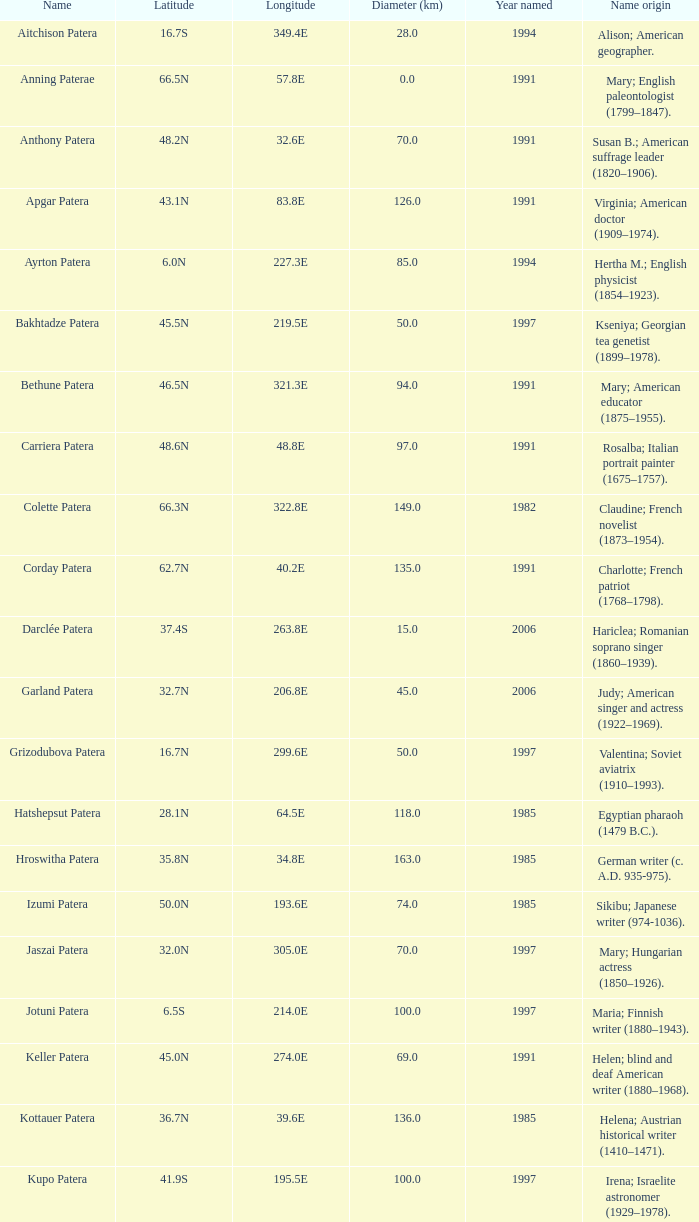2e? 135.0. Write the full table. {'header': ['Name', 'Latitude', 'Longitude', 'Diameter (km)', 'Year named', 'Name origin'], 'rows': [['Aitchison Patera', '16.7S', '349.4E', '28.0', '1994', 'Alison; American geographer.'], ['Anning Paterae', '66.5N', '57.8E', '0.0', '1991', 'Mary; English paleontologist (1799–1847).'], ['Anthony Patera', '48.2N', '32.6E', '70.0', '1991', 'Susan B.; American suffrage leader (1820–1906).'], ['Apgar Patera', '43.1N', '83.8E', '126.0', '1991', 'Virginia; American doctor (1909–1974).'], ['Ayrton Patera', '6.0N', '227.3E', '85.0', '1994', 'Hertha M.; English physicist (1854–1923).'], ['Bakhtadze Patera', '45.5N', '219.5E', '50.0', '1997', 'Kseniya; Georgian tea genetist (1899–1978).'], ['Bethune Patera', '46.5N', '321.3E', '94.0', '1991', 'Mary; American educator (1875–1955).'], ['Carriera Patera', '48.6N', '48.8E', '97.0', '1991', 'Rosalba; Italian portrait painter (1675–1757).'], ['Colette Patera', '66.3N', '322.8E', '149.0', '1982', 'Claudine; French novelist (1873–1954).'], ['Corday Patera', '62.7N', '40.2E', '135.0', '1991', 'Charlotte; French patriot (1768–1798).'], ['Darclée Patera', '37.4S', '263.8E', '15.0', '2006', 'Hariclea; Romanian soprano singer (1860–1939).'], ['Garland Patera', '32.7N', '206.8E', '45.0', '2006', 'Judy; American singer and actress (1922–1969).'], ['Grizodubova Patera', '16.7N', '299.6E', '50.0', '1997', 'Valentina; Soviet aviatrix (1910–1993).'], ['Hatshepsut Patera', '28.1N', '64.5E', '118.0', '1985', 'Egyptian pharaoh (1479 B.C.).'], ['Hroswitha Patera', '35.8N', '34.8E', '163.0', '1985', 'German writer (c. A.D. 935-975).'], ['Izumi Patera', '50.0N', '193.6E', '74.0', '1985', 'Sikibu; Japanese writer (974-1036).'], ['Jaszai Patera', '32.0N', '305.0E', '70.0', '1997', 'Mary; Hungarian actress (1850–1926).'], ['Jotuni Patera', '6.5S', '214.0E', '100.0', '1997', 'Maria; Finnish writer (1880–1943).'], ['Keller Patera', '45.0N', '274.0E', '69.0', '1991', 'Helen; blind and deaf American writer (1880–1968).'], ['Kottauer Patera', '36.7N', '39.6E', '136.0', '1985', 'Helena; Austrian historical writer (1410–1471).'], ['Kupo Patera', '41.9S', '195.5E', '100.0', '1997', 'Irena; Israelite astronomer (1929–1978).'], ['Ledoux Patera', '9.2S', '224.8E', '75.0', '1994', 'Jeanne; French artist (1767–1840).'], ['Lindgren Patera', '28.1N', '241.4E', '110.0', '2006', 'Astrid; Swedish author (1907–2002).'], ['Mehseti Patera', '16.0N', '311.0E', '60.0', '1997', 'Ganjevi; Azeri/Persian poet (c. 1050-c. 1100).'], ['Mezrina Patera', '33.3S', '68.8E', '60.0', '2000', 'Anna; Russian clay toy sculptor (1853–1938).'], ['Nordenflycht Patera', '35.0S', '266.0E', '140.0', '1997', 'Hedwig; Swedish poet (1718–1763).'], ['Panina Patera', '13.0S', '309.8E', '50.0', '1997', 'Varya; Gypsy/Russian singer (1872–1911).'], ['Payne-Gaposchkin Patera', '25.5S', '196.0E', '100.0', '1997', 'Cecilia Helena; American astronomer (1900–1979).'], ['Pocahontas Patera', '64.9N', '49.4E', '78.0', '1991', 'Powhatan Indian peacemaker (1595–1617).'], ['Raskova Paterae', '51.0S', '222.8E', '80.0', '1994', 'Marina M.; Russian aviator (1912–1943).'], ['Razia Patera', '46.2N', '197.8E', '157.0', '1985', 'Queen of Delhi Sultanate (India) (1236–1240).'], ['Shulzhenko Patera', '6.5N', '264.5E', '60.0', '1997', 'Klavdiya; Soviet singer (1906–1984).'], ['Siddons Patera', '61.6N', '340.6E', '47.0', '1997', 'Sarah; English actress (1755–1831).'], ['Stopes Patera', '42.6N', '46.5E', '169.0', '1991', 'Marie; English paleontologist (1880–1959).'], ['Tarbell Patera', '58.2S', '351.5E', '80.0', '1994', 'Ida; American author, editor (1857–1944).'], ['Teasdale Patera', '67.6S', '189.1E', '75.0', '1994', 'Sara; American poet (1884–1933).'], ['Tey Patera', '17.8S', '349.1E', '20.0', '1994', 'Josephine; Scottish author (1897–1952).'], ['Tipporah Patera', '38.9N', '43.0E', '99.0', '1985', 'Hebrew medical scholar (1500 B.C.).'], ['Vibert-Douglas Patera', '11.6S', '194.3E', '45.0', '2003', 'Allie; Canadian astronomer (1894–1988).'], ['Villepreux-Power Patera', '22.0S', '210.0E', '100.0', '1997', 'Jeannette; French marine biologist (1794–1871).'], ['Wilde Patera', '21.3S', '266.3E', '75.0', '2000', 'Lady Jane Francesca; Irish poet (1821–1891).'], ['Witte Patera', '25.8S', '247.65E', '35.0', '2006', 'Wilhelmine; German astronomer (1777–1854).'], ['Woodhull Patera', '37.4N', '305.4E', '83.0', '1991', 'Victoria; American-English lecturer (1838–1927).']]} 